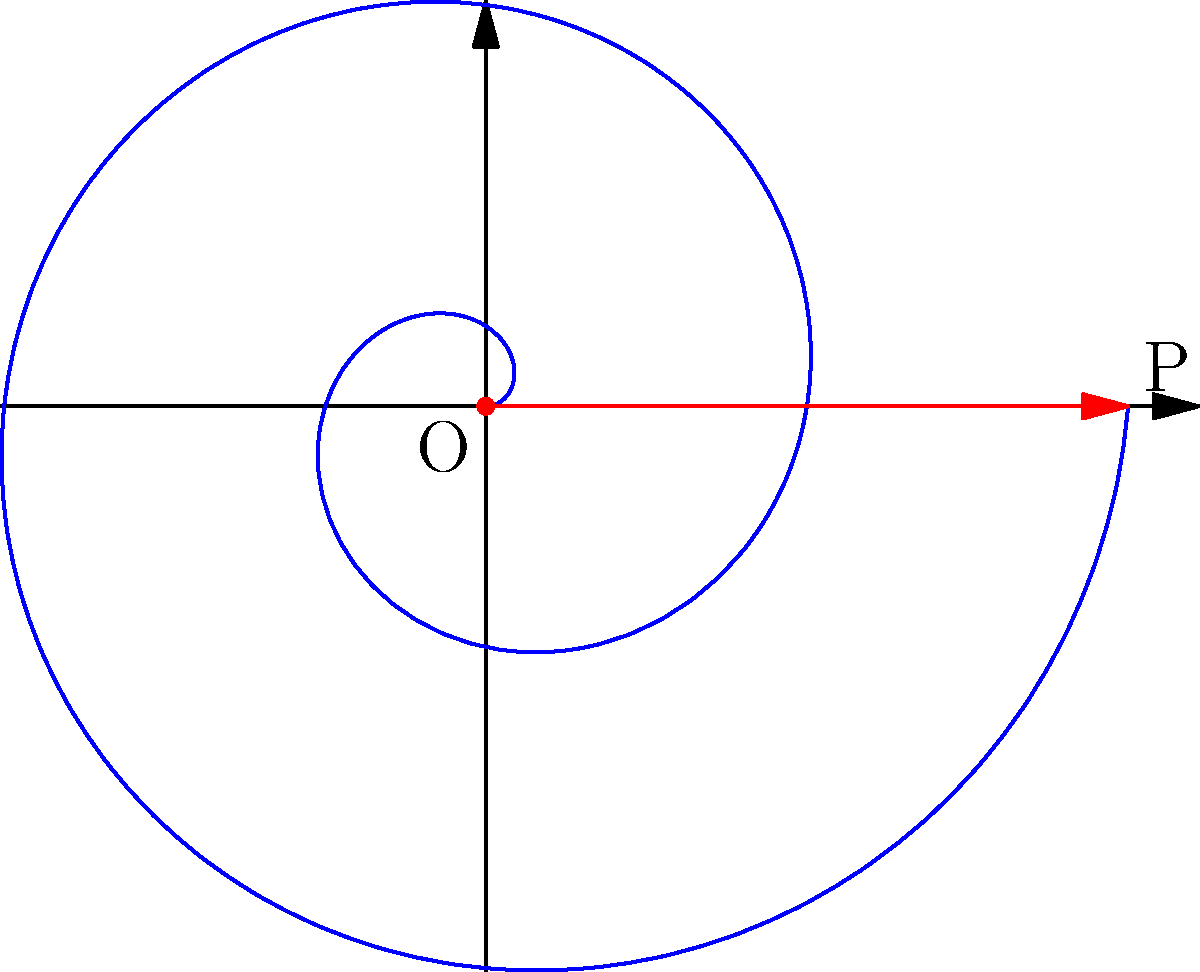In the melancholic spiral of life, a poet's pen traces a path like a record player's arm. The spiral is defined by the parametric equations $x = t \cos(t)$ and $y = t \sin(t)$, where $t$ represents time. If the spiral completes two full rotations, what is the total arc length of this poetic journey? Express your answer in terms of $\pi$. To find the arc length of the spiral, we'll follow these steps:

1) The arc length formula for a parametric curve is:
   
   $$L = \int_{a}^{b} \sqrt{\left(\frac{dx}{dt}\right)^2 + \left(\frac{dy}{dt}\right)^2} dt$$

2) We need to find $\frac{dx}{dt}$ and $\frac{dy}{dt}$:
   
   $\frac{dx}{dt} = \cos(t) - t\sin(t)$
   $\frac{dy}{dt} = \sin(t) + t\cos(t)$

3) Substituting into the arc length formula:
   
   $$L = \int_{0}^{4\pi} \sqrt{(\cos(t) - t\sin(t))^2 + (\sin(t) + t\cos(t))^2} dt$$

4) Simplify the expression under the square root:
   
   $$(\cos(t) - t\sin(t))^2 + (\sin(t) + t\cos(t))^2 = \cos^2(t) - 2t\cos(t)\sin(t) + t^2\sin^2(t) + \sin^2(t) + 2t\sin(t)\cos(t) + t^2\cos^2(t)$$
   
   $$= \cos^2(t) + \sin^2(t) + t^2(\sin^2(t) + \cos^2(t)) = 1 + t^2$$

5) Therefore, our integral simplifies to:
   
   $$L = \int_{0}^{4\pi} \sqrt{1 + t^2} dt$$

6) This integral doesn't have an elementary antiderivative. However, it can be evaluated to:
   
   $$L = \frac{1}{2}(t\sqrt{1+t^2} + \ln(t + \sqrt{1+t^2}))\bigg|_{0}^{4\pi}$$

7) Evaluating at the limits:
   
   $$L = \frac{1}{2}(4\pi\sqrt{1+(4\pi)^2} + \ln(4\pi + \sqrt{1+(4\pi)^2})) - 0$$

8) This can be approximated numerically to about $32.22$.
Answer: $\frac{1}{2}(4\pi\sqrt{1+(4\pi)^2} + \ln(4\pi + \sqrt{1+(4\pi)^2}))$ 